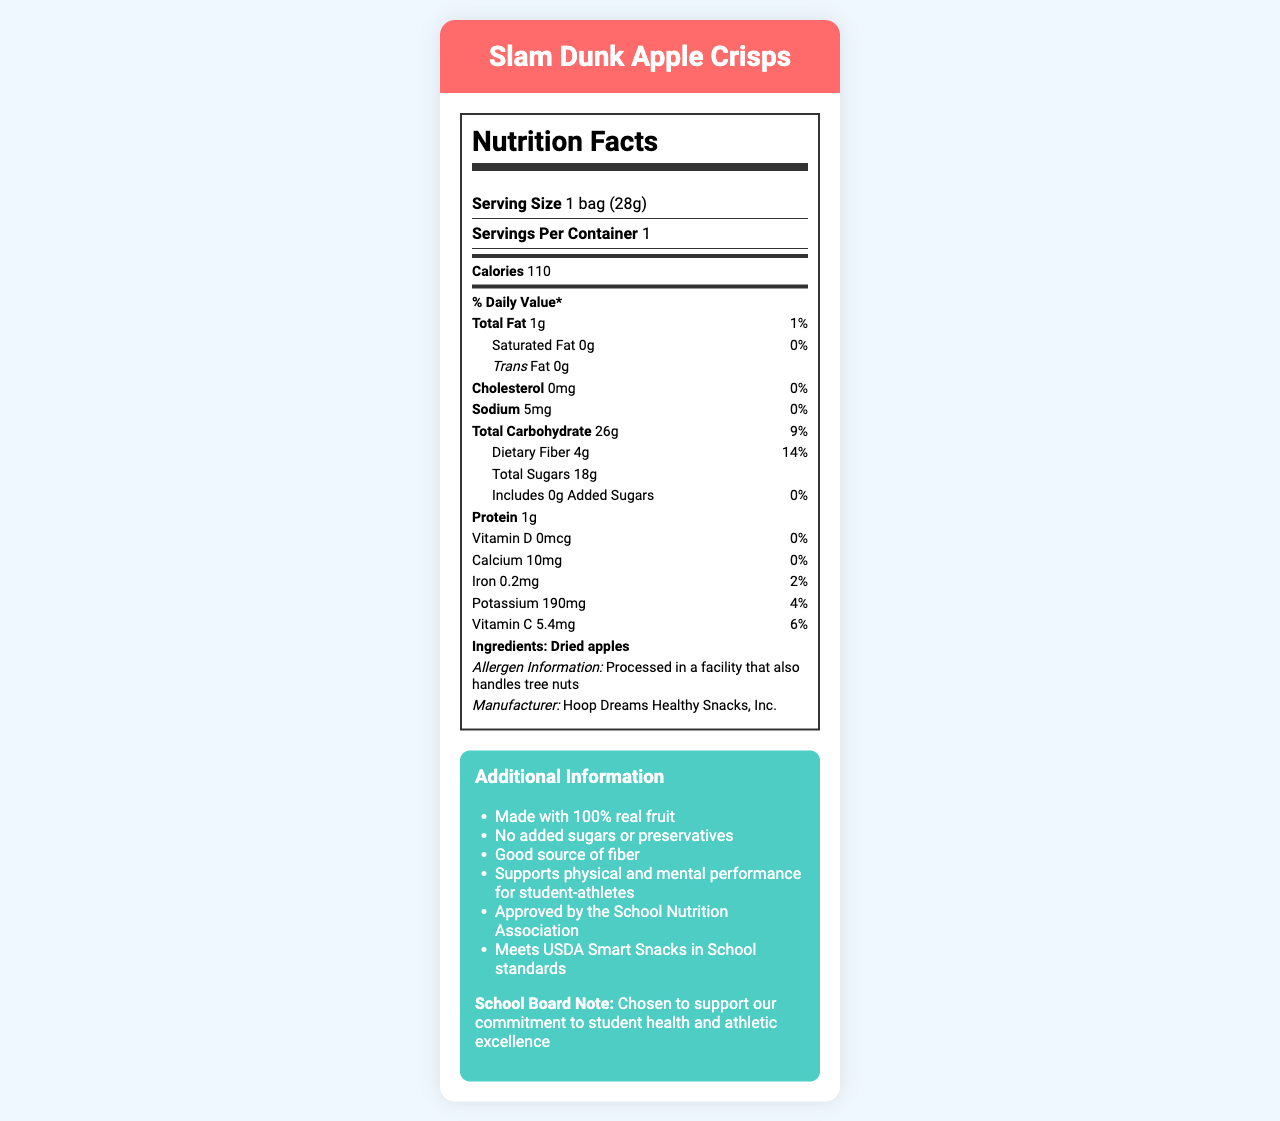what is the serving size? The document states that the serving size is 1 bag (28g) under the serving information.
Answer: 1 bag (28g) how many calories are in one serving? The Nutrition Facts section of the document lists 110 calories per serving.
Answer: 110 what is the protein content in one serving? The document mentions that there is 1g of protein per serving in the Nutrition Facts section.
Answer: 1g what are the ingredients of Slam Dunk Apple Crisps? The ingredients section specifies that the only ingredient is dried apples.
Answer: Dried apples which nutrient has the highest daily value percentage? The dietary fiber has a daily value percentage of 14%, which is the highest among all listed nutrients.
Answer: Dietary fiber, 14% how much sodium is in one serving? The document lists sodium content as 5mg.
Answer: 5mg does the product contain any added sugars? The document explicitly mentions "0g" for added sugars.
Answer: No what is the source of iron in this snack? The document does not specify the source of iron beyond listing the amount and daily value percentage.
Answer: Cannot be determined which organization approves the Slam Dunk Apple Crisps for school nutrition? A. USDA B. FDA C. School Nutrition Association The document lists "Approved by the School Nutrition Association" in the additional information section.
Answer: C how many servings are in one container? A. 1 B. 2 C. 3 D. 4 The serving information specifies that there is 1 serving per container.
Answer: A is this product processed in a facility that also handles tree nuts? The allergen information indicates that the product is processed in a facility that also handles tree nuts.
Answer: Yes does this product meet USDA Smart Snacks in School standards? The additional information confirms that the product meets USDA Smart Snacks in School standards.
Answer: Yes what is the main idea of the document? The document focuses on the nutritional content, ingredients, and additional endorsements to highlight the suitability of Slam Dunk Apple Crisps as a snack for school students.
Answer: The main idea of the document is to provide the Nutrition Facts for Slam Dunk Apple Crisps, a healthy snack option made of dried apples, which supports physical and mental performance for student-athletes and is approved by the School Nutrition Association. what is the total amount of sugars in one serving? The document lists total sugars as 18g in the Nutrition Facts section.
Answer: 18g 